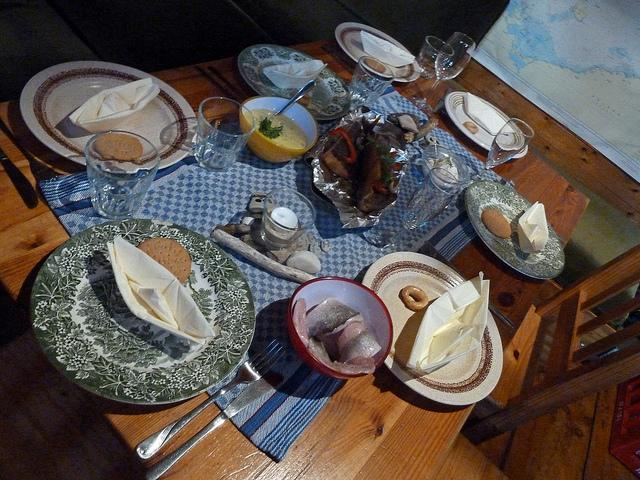What are the napkins folded to look like?

Choices:
A) boats
B) cars
C) plane
D) fans boats 